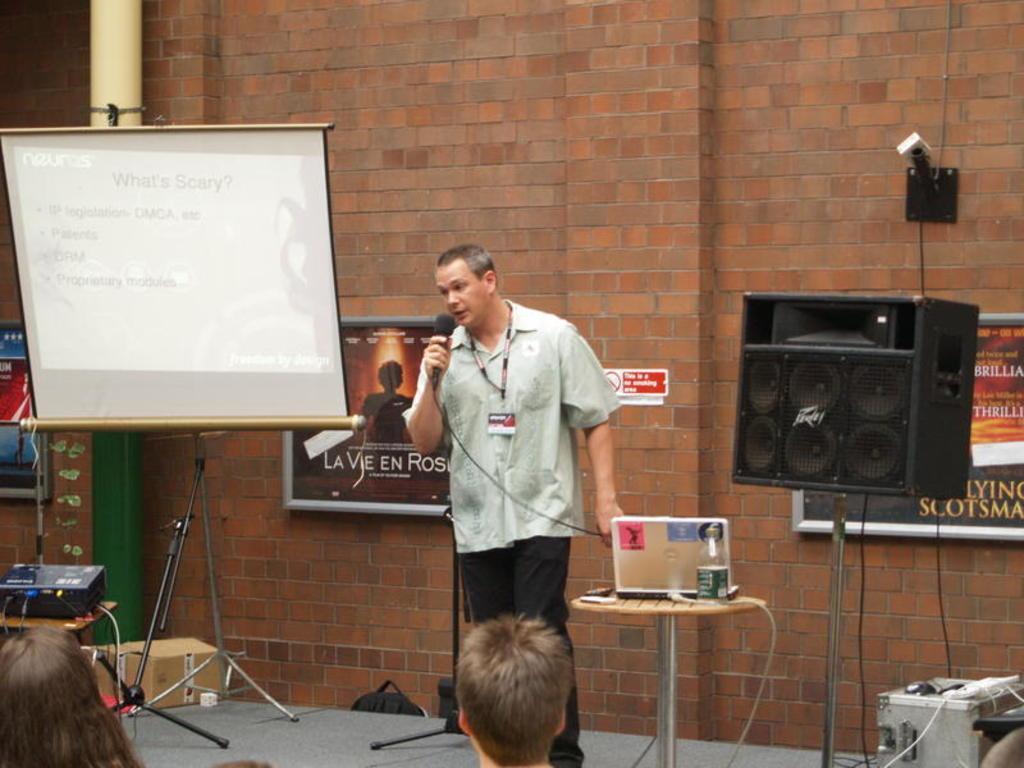Describe this image in one or two sentences. In this image there is a man standing on the stage and speaking in a microphone, beside him there is a table with some things on it, also there is a speaker box on the stand, on the left there is a projector screen and also there are banners on the wall behind him and some people sitting in front of him. 